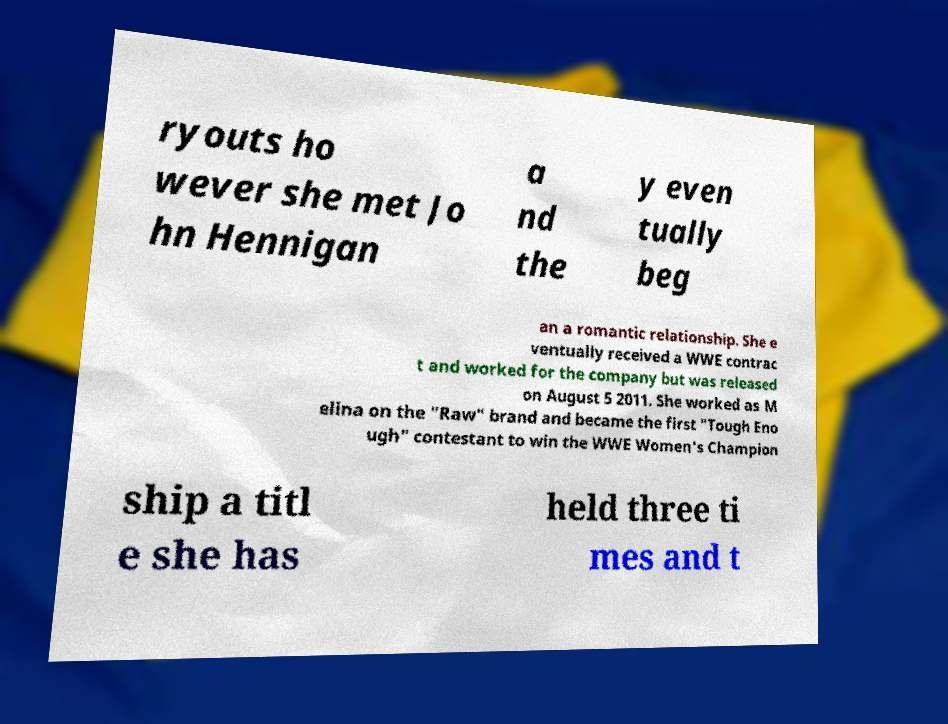Could you assist in decoding the text presented in this image and type it out clearly? ryouts ho wever she met Jo hn Hennigan a nd the y even tually beg an a romantic relationship. She e ventually received a WWE contrac t and worked for the company but was released on August 5 2011. She worked as M elina on the "Raw" brand and became the first "Tough Eno ugh" contestant to win the WWE Women's Champion ship a titl e she has held three ti mes and t 